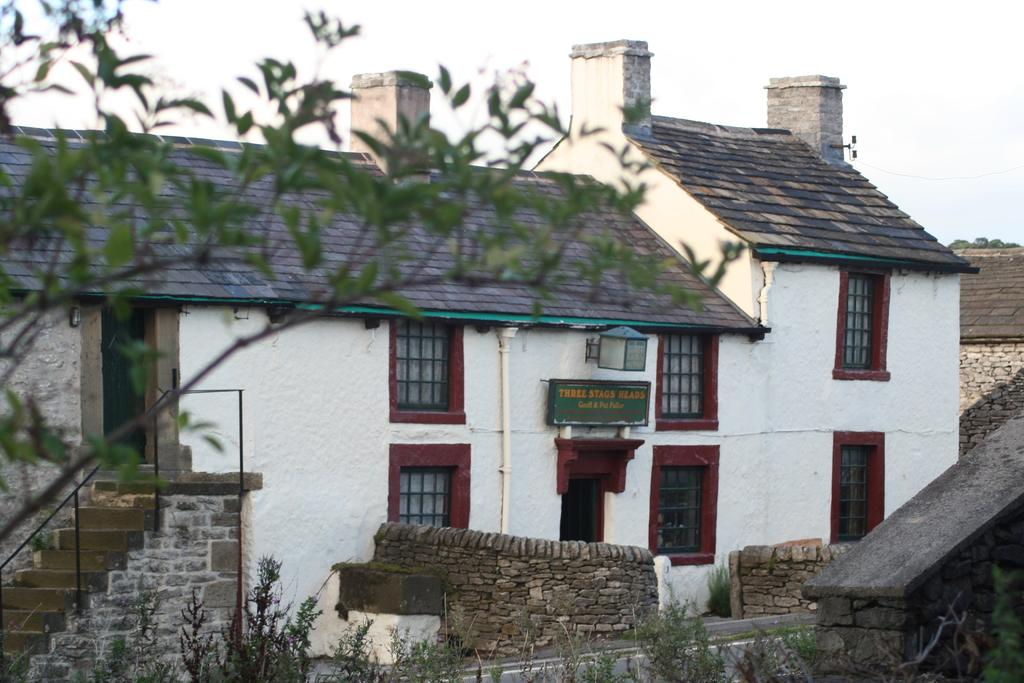What type of structures can be seen in the image? There are buildings in the image. What other natural elements are present in the image? There are trees in the image. What can be seen in the distance in the image? The sky is visible in the background of the image. What type of ink is used to write on the library's face in the image? There is no library or face present in the image, so it is not possible to determine what type of ink might be used. 